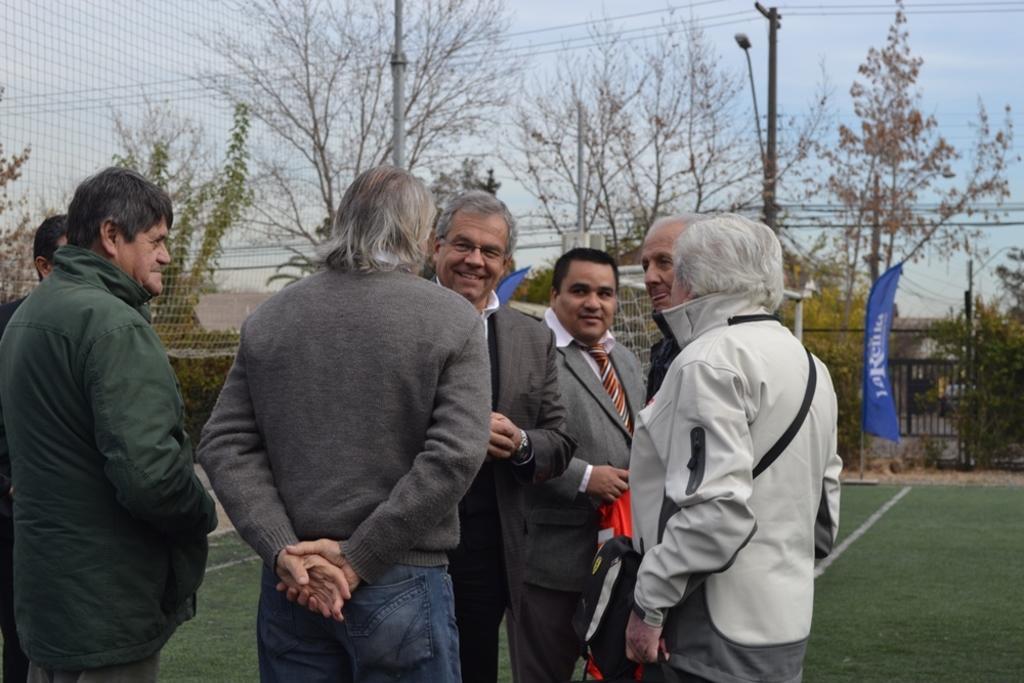Could you give a brief overview of what you see in this image? In this image I can see few people are standing. I can also see few of them are wearing jackets. In the background I can see few flags, white lines on ground, number of trees, wires, a pole and here I can see something is written. I can also see the sky in background. 